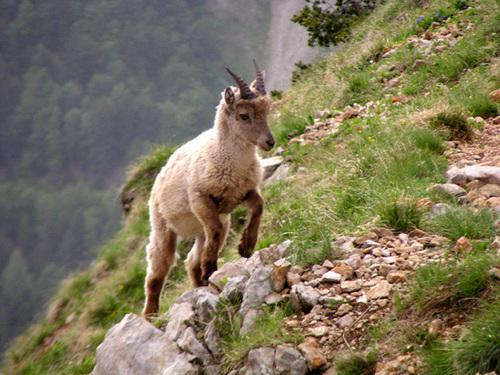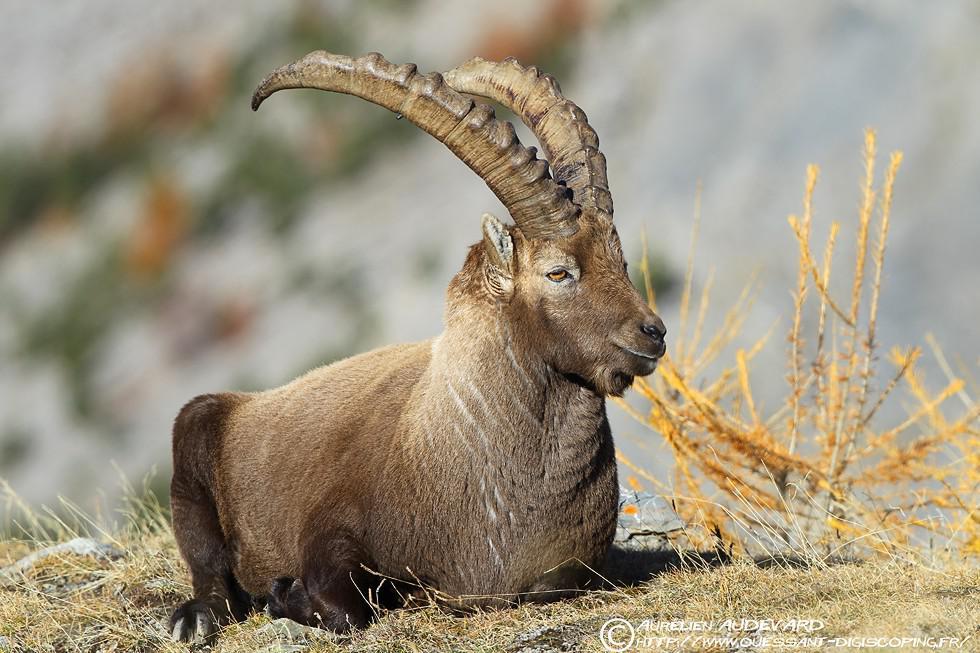The first image is the image on the left, the second image is the image on the right. Evaluate the accuracy of this statement regarding the images: "In one image, an antelope is resting with its body on the ground.". Is it true? Answer yes or no. Yes. 